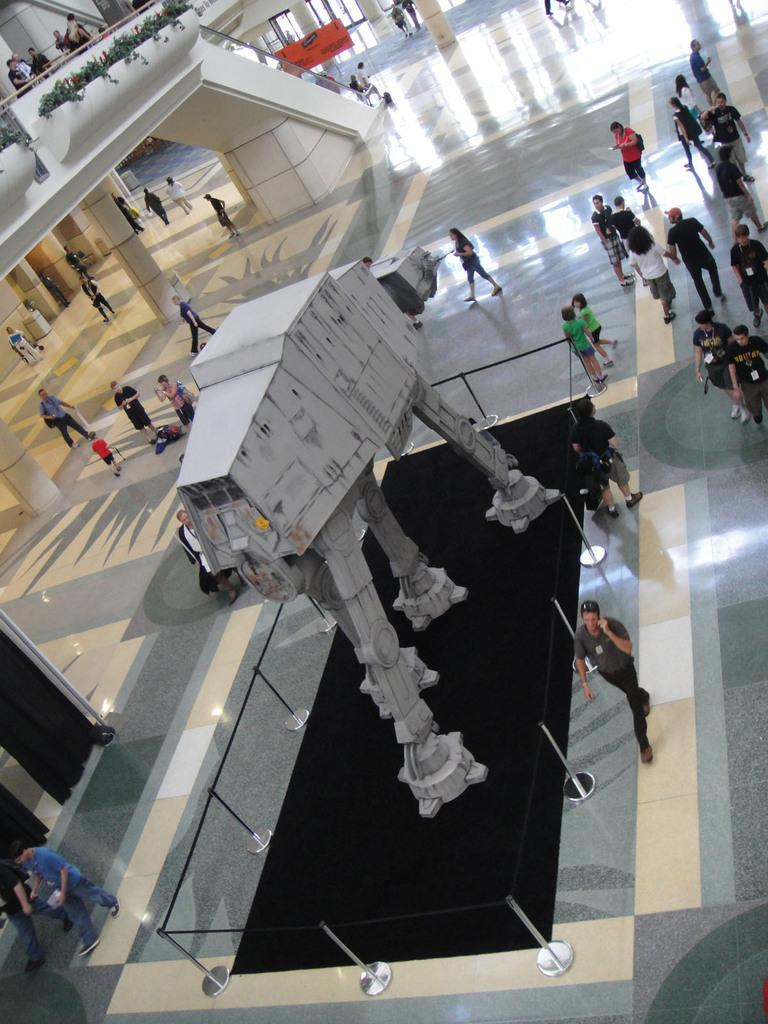Who or what can be seen in the image? There are people in the image. What are the people doing in the image? The people are walking or standing on the floor. What is the main feature in the middle of the image? There is a structure in the middle of the image. What type of underwear is being displayed on the structure in the image? There is no underwear present in the image, and the structure does not appear to be displaying any clothing items. 